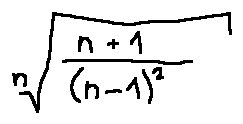Convert formula to latex. <formula><loc_0><loc_0><loc_500><loc_500>\sqrt { [ } n ] { \frac { n + 1 } { ( n - 1 ) ^ { 2 } } }</formula> 